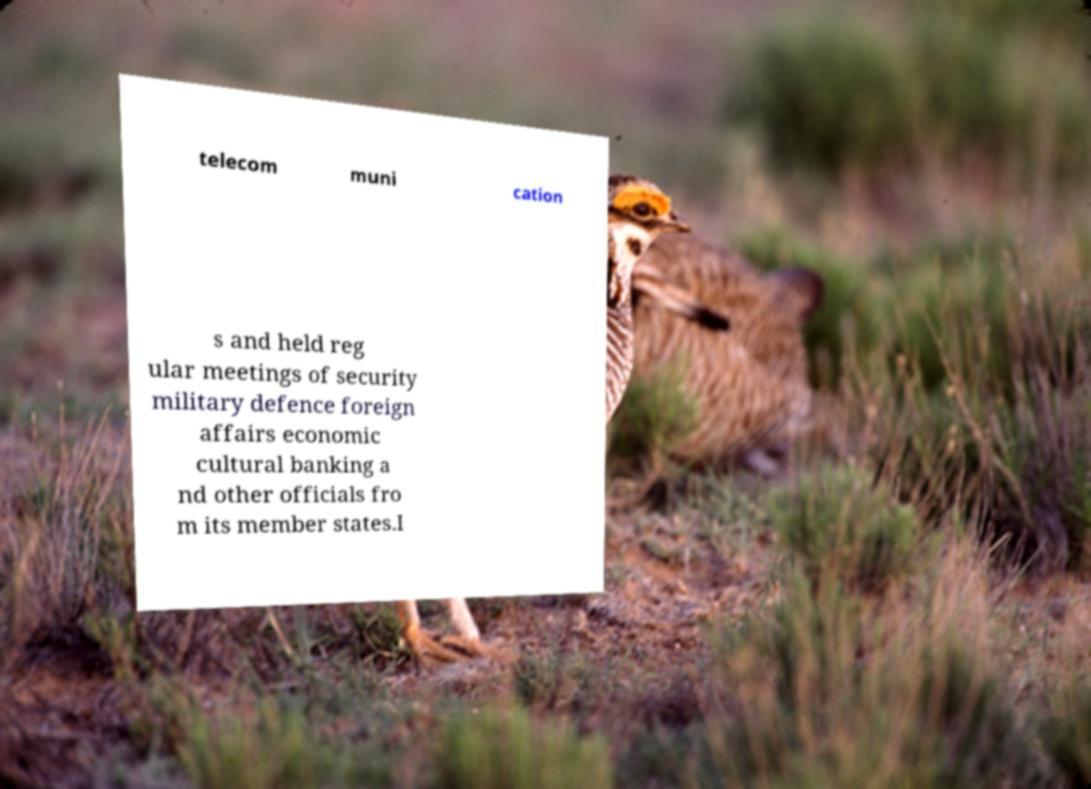Could you extract and type out the text from this image? telecom muni cation s and held reg ular meetings of security military defence foreign affairs economic cultural banking a nd other officials fro m its member states.I 